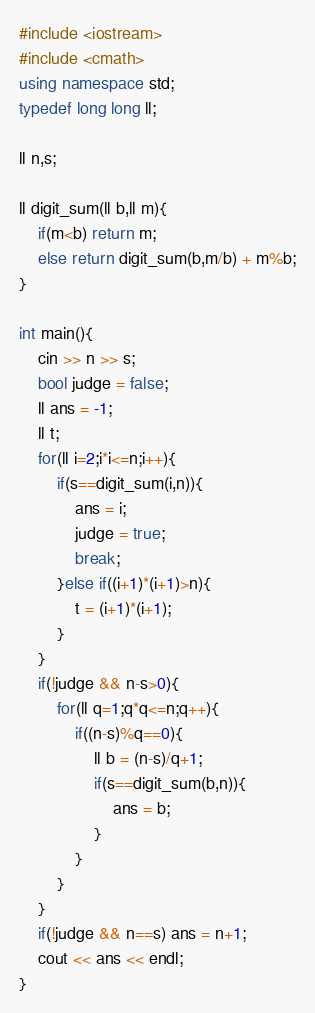<code> <loc_0><loc_0><loc_500><loc_500><_C++_>#include <iostream>
#include <cmath>
using namespace std;
typedef long long ll;

ll n,s;

ll digit_sum(ll b,ll m){
	if(m<b) return m;
	else return digit_sum(b,m/b) + m%b;
}

int main(){
	cin >> n >> s;
	bool judge = false;
	ll ans = -1;
	ll t;
	for(ll i=2;i*i<=n;i++){
		if(s==digit_sum(i,n)){
			ans = i;
			judge = true;
			break;
		}else if((i+1)*(i+1)>n){
			t = (i+1)*(i+1);
		}
	}
	if(!judge && n-s>0){
		for(ll q=1;q*q<=n;q++){
			if((n-s)%q==0){
				ll b = (n-s)/q+1;
				if(s==digit_sum(b,n)){
					ans = b;
				}
			}
		}
	}
	if(!judge && n==s) ans = n+1;
	cout << ans << endl;
}</code> 